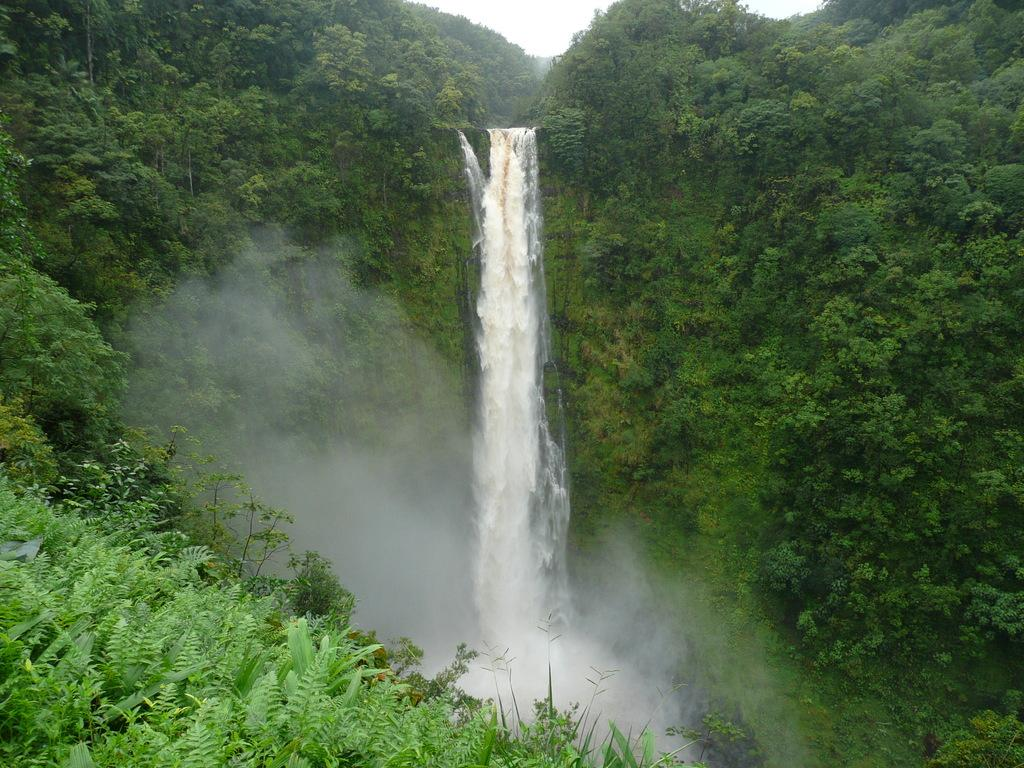What is the main feature in the center of the image? There is a waterfall in the center of the image. What type of natural environment is depicted in the image? The image is covered with plants and trees. Where is the station located in the image? There is no station present in the image; it features a waterfall and plants. What type of spot can be seen on the waterfall in the image? There are no spots visible on the waterfall in the image. 